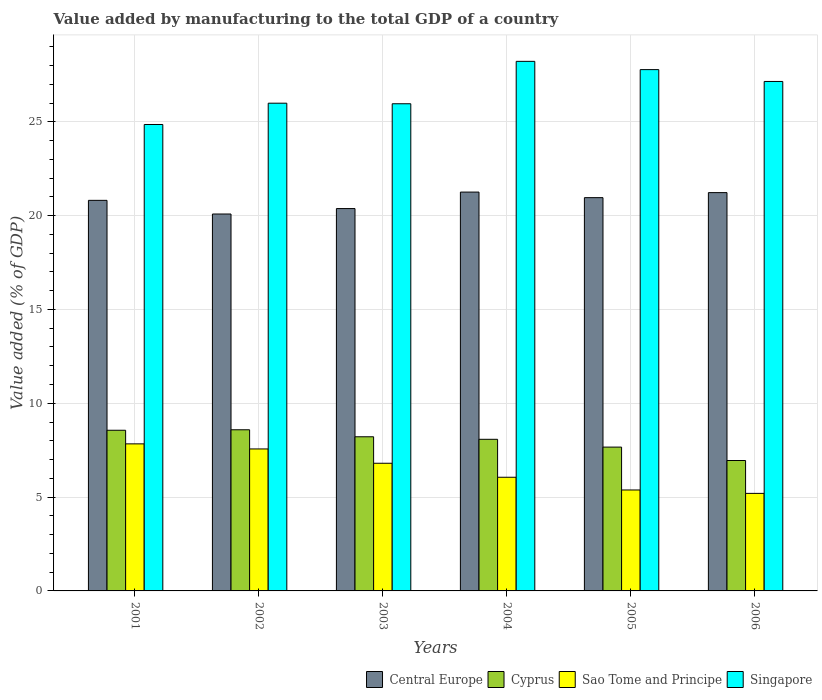Are the number of bars on each tick of the X-axis equal?
Provide a succinct answer. Yes. How many bars are there on the 6th tick from the left?
Provide a succinct answer. 4. How many bars are there on the 3rd tick from the right?
Offer a terse response. 4. What is the label of the 4th group of bars from the left?
Keep it short and to the point. 2004. What is the value added by manufacturing to the total GDP in Sao Tome and Principe in 2003?
Make the answer very short. 6.8. Across all years, what is the maximum value added by manufacturing to the total GDP in Sao Tome and Principe?
Provide a short and direct response. 7.84. Across all years, what is the minimum value added by manufacturing to the total GDP in Singapore?
Make the answer very short. 24.86. What is the total value added by manufacturing to the total GDP in Cyprus in the graph?
Ensure brevity in your answer.  48.06. What is the difference between the value added by manufacturing to the total GDP in Central Europe in 2001 and that in 2005?
Make the answer very short. -0.14. What is the difference between the value added by manufacturing to the total GDP in Central Europe in 2005 and the value added by manufacturing to the total GDP in Sao Tome and Principe in 2002?
Your answer should be compact. 13.39. What is the average value added by manufacturing to the total GDP in Sao Tome and Principe per year?
Make the answer very short. 6.47. In the year 2002, what is the difference between the value added by manufacturing to the total GDP in Central Europe and value added by manufacturing to the total GDP in Sao Tome and Principe?
Offer a terse response. 12.52. In how many years, is the value added by manufacturing to the total GDP in Cyprus greater than 2 %?
Keep it short and to the point. 6. What is the ratio of the value added by manufacturing to the total GDP in Cyprus in 2003 to that in 2006?
Provide a short and direct response. 1.18. Is the difference between the value added by manufacturing to the total GDP in Central Europe in 2001 and 2005 greater than the difference between the value added by manufacturing to the total GDP in Sao Tome and Principe in 2001 and 2005?
Offer a very short reply. No. What is the difference between the highest and the second highest value added by manufacturing to the total GDP in Singapore?
Provide a succinct answer. 0.44. What is the difference between the highest and the lowest value added by manufacturing to the total GDP in Cyprus?
Ensure brevity in your answer.  1.64. What does the 2nd bar from the left in 2002 represents?
Make the answer very short. Cyprus. What does the 3rd bar from the right in 2004 represents?
Ensure brevity in your answer.  Cyprus. How many bars are there?
Your response must be concise. 24. How many years are there in the graph?
Offer a terse response. 6. What is the difference between two consecutive major ticks on the Y-axis?
Your answer should be very brief. 5. Are the values on the major ticks of Y-axis written in scientific E-notation?
Offer a terse response. No. Does the graph contain grids?
Your answer should be compact. Yes. How are the legend labels stacked?
Make the answer very short. Horizontal. What is the title of the graph?
Keep it short and to the point. Value added by manufacturing to the total GDP of a country. What is the label or title of the X-axis?
Your response must be concise. Years. What is the label or title of the Y-axis?
Make the answer very short. Value added (% of GDP). What is the Value added (% of GDP) of Central Europe in 2001?
Ensure brevity in your answer.  20.81. What is the Value added (% of GDP) of Cyprus in 2001?
Give a very brief answer. 8.56. What is the Value added (% of GDP) in Sao Tome and Principe in 2001?
Make the answer very short. 7.84. What is the Value added (% of GDP) in Singapore in 2001?
Offer a very short reply. 24.86. What is the Value added (% of GDP) in Central Europe in 2002?
Provide a short and direct response. 20.09. What is the Value added (% of GDP) in Cyprus in 2002?
Make the answer very short. 8.59. What is the Value added (% of GDP) of Sao Tome and Principe in 2002?
Your answer should be very brief. 7.57. What is the Value added (% of GDP) in Singapore in 2002?
Provide a succinct answer. 25.99. What is the Value added (% of GDP) of Central Europe in 2003?
Provide a short and direct response. 20.38. What is the Value added (% of GDP) of Cyprus in 2003?
Offer a terse response. 8.21. What is the Value added (% of GDP) in Sao Tome and Principe in 2003?
Offer a terse response. 6.8. What is the Value added (% of GDP) of Singapore in 2003?
Give a very brief answer. 25.96. What is the Value added (% of GDP) of Central Europe in 2004?
Your answer should be very brief. 21.25. What is the Value added (% of GDP) in Cyprus in 2004?
Ensure brevity in your answer.  8.08. What is the Value added (% of GDP) of Sao Tome and Principe in 2004?
Provide a succinct answer. 6.06. What is the Value added (% of GDP) of Singapore in 2004?
Make the answer very short. 28.22. What is the Value added (% of GDP) of Central Europe in 2005?
Ensure brevity in your answer.  20.96. What is the Value added (% of GDP) in Cyprus in 2005?
Offer a terse response. 7.66. What is the Value added (% of GDP) of Sao Tome and Principe in 2005?
Provide a succinct answer. 5.38. What is the Value added (% of GDP) in Singapore in 2005?
Give a very brief answer. 27.78. What is the Value added (% of GDP) in Central Europe in 2006?
Your response must be concise. 21.23. What is the Value added (% of GDP) of Cyprus in 2006?
Offer a terse response. 6.95. What is the Value added (% of GDP) in Sao Tome and Principe in 2006?
Make the answer very short. 5.2. What is the Value added (% of GDP) of Singapore in 2006?
Give a very brief answer. 27.15. Across all years, what is the maximum Value added (% of GDP) of Central Europe?
Give a very brief answer. 21.25. Across all years, what is the maximum Value added (% of GDP) in Cyprus?
Offer a terse response. 8.59. Across all years, what is the maximum Value added (% of GDP) of Sao Tome and Principe?
Your response must be concise. 7.84. Across all years, what is the maximum Value added (% of GDP) of Singapore?
Give a very brief answer. 28.22. Across all years, what is the minimum Value added (% of GDP) of Central Europe?
Make the answer very short. 20.09. Across all years, what is the minimum Value added (% of GDP) in Cyprus?
Ensure brevity in your answer.  6.95. Across all years, what is the minimum Value added (% of GDP) of Sao Tome and Principe?
Provide a succinct answer. 5.2. Across all years, what is the minimum Value added (% of GDP) in Singapore?
Ensure brevity in your answer.  24.86. What is the total Value added (% of GDP) in Central Europe in the graph?
Ensure brevity in your answer.  124.71. What is the total Value added (% of GDP) of Cyprus in the graph?
Make the answer very short. 48.06. What is the total Value added (% of GDP) in Sao Tome and Principe in the graph?
Make the answer very short. 38.84. What is the total Value added (% of GDP) in Singapore in the graph?
Provide a succinct answer. 159.96. What is the difference between the Value added (% of GDP) in Central Europe in 2001 and that in 2002?
Your answer should be compact. 0.73. What is the difference between the Value added (% of GDP) of Cyprus in 2001 and that in 2002?
Your answer should be very brief. -0.03. What is the difference between the Value added (% of GDP) in Sao Tome and Principe in 2001 and that in 2002?
Provide a short and direct response. 0.27. What is the difference between the Value added (% of GDP) in Singapore in 2001 and that in 2002?
Your answer should be very brief. -1.13. What is the difference between the Value added (% of GDP) in Central Europe in 2001 and that in 2003?
Offer a terse response. 0.44. What is the difference between the Value added (% of GDP) in Cyprus in 2001 and that in 2003?
Keep it short and to the point. 0.35. What is the difference between the Value added (% of GDP) of Sao Tome and Principe in 2001 and that in 2003?
Your response must be concise. 1.03. What is the difference between the Value added (% of GDP) in Singapore in 2001 and that in 2003?
Make the answer very short. -1.1. What is the difference between the Value added (% of GDP) of Central Europe in 2001 and that in 2004?
Give a very brief answer. -0.44. What is the difference between the Value added (% of GDP) of Cyprus in 2001 and that in 2004?
Provide a short and direct response. 0.48. What is the difference between the Value added (% of GDP) of Sao Tome and Principe in 2001 and that in 2004?
Offer a terse response. 1.78. What is the difference between the Value added (% of GDP) of Singapore in 2001 and that in 2004?
Keep it short and to the point. -3.36. What is the difference between the Value added (% of GDP) in Central Europe in 2001 and that in 2005?
Offer a very short reply. -0.14. What is the difference between the Value added (% of GDP) of Cyprus in 2001 and that in 2005?
Provide a short and direct response. 0.9. What is the difference between the Value added (% of GDP) in Sao Tome and Principe in 2001 and that in 2005?
Provide a succinct answer. 2.46. What is the difference between the Value added (% of GDP) in Singapore in 2001 and that in 2005?
Your answer should be very brief. -2.92. What is the difference between the Value added (% of GDP) of Central Europe in 2001 and that in 2006?
Offer a very short reply. -0.41. What is the difference between the Value added (% of GDP) in Cyprus in 2001 and that in 2006?
Provide a succinct answer. 1.61. What is the difference between the Value added (% of GDP) in Sao Tome and Principe in 2001 and that in 2006?
Your answer should be very brief. 2.64. What is the difference between the Value added (% of GDP) in Singapore in 2001 and that in 2006?
Make the answer very short. -2.29. What is the difference between the Value added (% of GDP) of Central Europe in 2002 and that in 2003?
Give a very brief answer. -0.29. What is the difference between the Value added (% of GDP) in Cyprus in 2002 and that in 2003?
Offer a very short reply. 0.37. What is the difference between the Value added (% of GDP) in Sao Tome and Principe in 2002 and that in 2003?
Make the answer very short. 0.76. What is the difference between the Value added (% of GDP) of Singapore in 2002 and that in 2003?
Your answer should be compact. 0.03. What is the difference between the Value added (% of GDP) of Central Europe in 2002 and that in 2004?
Your response must be concise. -1.17. What is the difference between the Value added (% of GDP) of Cyprus in 2002 and that in 2004?
Your answer should be compact. 0.51. What is the difference between the Value added (% of GDP) in Sao Tome and Principe in 2002 and that in 2004?
Keep it short and to the point. 1.51. What is the difference between the Value added (% of GDP) in Singapore in 2002 and that in 2004?
Offer a very short reply. -2.23. What is the difference between the Value added (% of GDP) of Central Europe in 2002 and that in 2005?
Offer a terse response. -0.87. What is the difference between the Value added (% of GDP) of Cyprus in 2002 and that in 2005?
Your answer should be compact. 0.92. What is the difference between the Value added (% of GDP) of Sao Tome and Principe in 2002 and that in 2005?
Ensure brevity in your answer.  2.19. What is the difference between the Value added (% of GDP) of Singapore in 2002 and that in 2005?
Ensure brevity in your answer.  -1.79. What is the difference between the Value added (% of GDP) of Central Europe in 2002 and that in 2006?
Give a very brief answer. -1.14. What is the difference between the Value added (% of GDP) in Cyprus in 2002 and that in 2006?
Your response must be concise. 1.64. What is the difference between the Value added (% of GDP) of Sao Tome and Principe in 2002 and that in 2006?
Provide a succinct answer. 2.37. What is the difference between the Value added (% of GDP) in Singapore in 2002 and that in 2006?
Ensure brevity in your answer.  -1.16. What is the difference between the Value added (% of GDP) in Central Europe in 2003 and that in 2004?
Ensure brevity in your answer.  -0.88. What is the difference between the Value added (% of GDP) in Cyprus in 2003 and that in 2004?
Ensure brevity in your answer.  0.14. What is the difference between the Value added (% of GDP) in Sao Tome and Principe in 2003 and that in 2004?
Your answer should be compact. 0.75. What is the difference between the Value added (% of GDP) of Singapore in 2003 and that in 2004?
Provide a succinct answer. -2.26. What is the difference between the Value added (% of GDP) of Central Europe in 2003 and that in 2005?
Your answer should be compact. -0.58. What is the difference between the Value added (% of GDP) in Cyprus in 2003 and that in 2005?
Provide a short and direct response. 0.55. What is the difference between the Value added (% of GDP) in Sao Tome and Principe in 2003 and that in 2005?
Keep it short and to the point. 1.42. What is the difference between the Value added (% of GDP) in Singapore in 2003 and that in 2005?
Offer a very short reply. -1.82. What is the difference between the Value added (% of GDP) of Central Europe in 2003 and that in 2006?
Make the answer very short. -0.85. What is the difference between the Value added (% of GDP) of Cyprus in 2003 and that in 2006?
Your response must be concise. 1.27. What is the difference between the Value added (% of GDP) in Sao Tome and Principe in 2003 and that in 2006?
Give a very brief answer. 1.61. What is the difference between the Value added (% of GDP) in Singapore in 2003 and that in 2006?
Offer a very short reply. -1.19. What is the difference between the Value added (% of GDP) in Central Europe in 2004 and that in 2005?
Your answer should be very brief. 0.3. What is the difference between the Value added (% of GDP) of Cyprus in 2004 and that in 2005?
Offer a very short reply. 0.42. What is the difference between the Value added (% of GDP) of Sao Tome and Principe in 2004 and that in 2005?
Offer a terse response. 0.68. What is the difference between the Value added (% of GDP) in Singapore in 2004 and that in 2005?
Your response must be concise. 0.44. What is the difference between the Value added (% of GDP) in Central Europe in 2004 and that in 2006?
Provide a succinct answer. 0.03. What is the difference between the Value added (% of GDP) in Cyprus in 2004 and that in 2006?
Provide a short and direct response. 1.13. What is the difference between the Value added (% of GDP) in Sao Tome and Principe in 2004 and that in 2006?
Provide a short and direct response. 0.86. What is the difference between the Value added (% of GDP) of Singapore in 2004 and that in 2006?
Make the answer very short. 1.07. What is the difference between the Value added (% of GDP) in Central Europe in 2005 and that in 2006?
Your response must be concise. -0.27. What is the difference between the Value added (% of GDP) of Cyprus in 2005 and that in 2006?
Ensure brevity in your answer.  0.71. What is the difference between the Value added (% of GDP) of Sao Tome and Principe in 2005 and that in 2006?
Offer a terse response. 0.18. What is the difference between the Value added (% of GDP) in Singapore in 2005 and that in 2006?
Offer a terse response. 0.63. What is the difference between the Value added (% of GDP) in Central Europe in 2001 and the Value added (% of GDP) in Cyprus in 2002?
Your answer should be compact. 12.23. What is the difference between the Value added (% of GDP) of Central Europe in 2001 and the Value added (% of GDP) of Sao Tome and Principe in 2002?
Provide a succinct answer. 13.25. What is the difference between the Value added (% of GDP) of Central Europe in 2001 and the Value added (% of GDP) of Singapore in 2002?
Your response must be concise. -5.18. What is the difference between the Value added (% of GDP) of Cyprus in 2001 and the Value added (% of GDP) of Singapore in 2002?
Offer a terse response. -17.43. What is the difference between the Value added (% of GDP) of Sao Tome and Principe in 2001 and the Value added (% of GDP) of Singapore in 2002?
Make the answer very short. -18.15. What is the difference between the Value added (% of GDP) in Central Europe in 2001 and the Value added (% of GDP) in Cyprus in 2003?
Your answer should be compact. 12.6. What is the difference between the Value added (% of GDP) in Central Europe in 2001 and the Value added (% of GDP) in Sao Tome and Principe in 2003?
Your response must be concise. 14.01. What is the difference between the Value added (% of GDP) in Central Europe in 2001 and the Value added (% of GDP) in Singapore in 2003?
Give a very brief answer. -5.15. What is the difference between the Value added (% of GDP) of Cyprus in 2001 and the Value added (% of GDP) of Sao Tome and Principe in 2003?
Offer a terse response. 1.76. What is the difference between the Value added (% of GDP) in Cyprus in 2001 and the Value added (% of GDP) in Singapore in 2003?
Ensure brevity in your answer.  -17.4. What is the difference between the Value added (% of GDP) in Sao Tome and Principe in 2001 and the Value added (% of GDP) in Singapore in 2003?
Your answer should be compact. -18.12. What is the difference between the Value added (% of GDP) of Central Europe in 2001 and the Value added (% of GDP) of Cyprus in 2004?
Your answer should be very brief. 12.73. What is the difference between the Value added (% of GDP) of Central Europe in 2001 and the Value added (% of GDP) of Sao Tome and Principe in 2004?
Your answer should be very brief. 14.76. What is the difference between the Value added (% of GDP) in Central Europe in 2001 and the Value added (% of GDP) in Singapore in 2004?
Provide a succinct answer. -7.41. What is the difference between the Value added (% of GDP) of Cyprus in 2001 and the Value added (% of GDP) of Sao Tome and Principe in 2004?
Give a very brief answer. 2.5. What is the difference between the Value added (% of GDP) in Cyprus in 2001 and the Value added (% of GDP) in Singapore in 2004?
Offer a very short reply. -19.66. What is the difference between the Value added (% of GDP) of Sao Tome and Principe in 2001 and the Value added (% of GDP) of Singapore in 2004?
Keep it short and to the point. -20.38. What is the difference between the Value added (% of GDP) in Central Europe in 2001 and the Value added (% of GDP) in Cyprus in 2005?
Offer a very short reply. 13.15. What is the difference between the Value added (% of GDP) in Central Europe in 2001 and the Value added (% of GDP) in Sao Tome and Principe in 2005?
Your response must be concise. 15.43. What is the difference between the Value added (% of GDP) in Central Europe in 2001 and the Value added (% of GDP) in Singapore in 2005?
Make the answer very short. -6.97. What is the difference between the Value added (% of GDP) in Cyprus in 2001 and the Value added (% of GDP) in Sao Tome and Principe in 2005?
Your answer should be very brief. 3.18. What is the difference between the Value added (% of GDP) in Cyprus in 2001 and the Value added (% of GDP) in Singapore in 2005?
Offer a very short reply. -19.22. What is the difference between the Value added (% of GDP) in Sao Tome and Principe in 2001 and the Value added (% of GDP) in Singapore in 2005?
Provide a short and direct response. -19.94. What is the difference between the Value added (% of GDP) of Central Europe in 2001 and the Value added (% of GDP) of Cyprus in 2006?
Offer a terse response. 13.86. What is the difference between the Value added (% of GDP) in Central Europe in 2001 and the Value added (% of GDP) in Sao Tome and Principe in 2006?
Provide a short and direct response. 15.62. What is the difference between the Value added (% of GDP) of Central Europe in 2001 and the Value added (% of GDP) of Singapore in 2006?
Your answer should be compact. -6.34. What is the difference between the Value added (% of GDP) of Cyprus in 2001 and the Value added (% of GDP) of Sao Tome and Principe in 2006?
Keep it short and to the point. 3.36. What is the difference between the Value added (% of GDP) in Cyprus in 2001 and the Value added (% of GDP) in Singapore in 2006?
Make the answer very short. -18.59. What is the difference between the Value added (% of GDP) of Sao Tome and Principe in 2001 and the Value added (% of GDP) of Singapore in 2006?
Offer a very short reply. -19.31. What is the difference between the Value added (% of GDP) in Central Europe in 2002 and the Value added (% of GDP) in Cyprus in 2003?
Provide a short and direct response. 11.87. What is the difference between the Value added (% of GDP) in Central Europe in 2002 and the Value added (% of GDP) in Sao Tome and Principe in 2003?
Make the answer very short. 13.28. What is the difference between the Value added (% of GDP) of Central Europe in 2002 and the Value added (% of GDP) of Singapore in 2003?
Your answer should be compact. -5.88. What is the difference between the Value added (% of GDP) in Cyprus in 2002 and the Value added (% of GDP) in Sao Tome and Principe in 2003?
Give a very brief answer. 1.78. What is the difference between the Value added (% of GDP) of Cyprus in 2002 and the Value added (% of GDP) of Singapore in 2003?
Offer a terse response. -17.37. What is the difference between the Value added (% of GDP) of Sao Tome and Principe in 2002 and the Value added (% of GDP) of Singapore in 2003?
Keep it short and to the point. -18.4. What is the difference between the Value added (% of GDP) of Central Europe in 2002 and the Value added (% of GDP) of Cyprus in 2004?
Offer a terse response. 12.01. What is the difference between the Value added (% of GDP) in Central Europe in 2002 and the Value added (% of GDP) in Sao Tome and Principe in 2004?
Keep it short and to the point. 14.03. What is the difference between the Value added (% of GDP) of Central Europe in 2002 and the Value added (% of GDP) of Singapore in 2004?
Your answer should be compact. -8.14. What is the difference between the Value added (% of GDP) in Cyprus in 2002 and the Value added (% of GDP) in Sao Tome and Principe in 2004?
Make the answer very short. 2.53. What is the difference between the Value added (% of GDP) in Cyprus in 2002 and the Value added (% of GDP) in Singapore in 2004?
Provide a succinct answer. -19.63. What is the difference between the Value added (% of GDP) in Sao Tome and Principe in 2002 and the Value added (% of GDP) in Singapore in 2004?
Keep it short and to the point. -20.66. What is the difference between the Value added (% of GDP) of Central Europe in 2002 and the Value added (% of GDP) of Cyprus in 2005?
Offer a terse response. 12.42. What is the difference between the Value added (% of GDP) of Central Europe in 2002 and the Value added (% of GDP) of Sao Tome and Principe in 2005?
Keep it short and to the point. 14.71. What is the difference between the Value added (% of GDP) in Central Europe in 2002 and the Value added (% of GDP) in Singapore in 2005?
Your response must be concise. -7.7. What is the difference between the Value added (% of GDP) of Cyprus in 2002 and the Value added (% of GDP) of Sao Tome and Principe in 2005?
Offer a terse response. 3.21. What is the difference between the Value added (% of GDP) in Cyprus in 2002 and the Value added (% of GDP) in Singapore in 2005?
Make the answer very short. -19.19. What is the difference between the Value added (% of GDP) in Sao Tome and Principe in 2002 and the Value added (% of GDP) in Singapore in 2005?
Ensure brevity in your answer.  -20.22. What is the difference between the Value added (% of GDP) in Central Europe in 2002 and the Value added (% of GDP) in Cyprus in 2006?
Your answer should be very brief. 13.14. What is the difference between the Value added (% of GDP) of Central Europe in 2002 and the Value added (% of GDP) of Sao Tome and Principe in 2006?
Ensure brevity in your answer.  14.89. What is the difference between the Value added (% of GDP) in Central Europe in 2002 and the Value added (% of GDP) in Singapore in 2006?
Give a very brief answer. -7.06. What is the difference between the Value added (% of GDP) of Cyprus in 2002 and the Value added (% of GDP) of Sao Tome and Principe in 2006?
Your answer should be very brief. 3.39. What is the difference between the Value added (% of GDP) in Cyprus in 2002 and the Value added (% of GDP) in Singapore in 2006?
Make the answer very short. -18.56. What is the difference between the Value added (% of GDP) of Sao Tome and Principe in 2002 and the Value added (% of GDP) of Singapore in 2006?
Provide a succinct answer. -19.58. What is the difference between the Value added (% of GDP) of Central Europe in 2003 and the Value added (% of GDP) of Cyprus in 2004?
Give a very brief answer. 12.3. What is the difference between the Value added (% of GDP) in Central Europe in 2003 and the Value added (% of GDP) in Sao Tome and Principe in 2004?
Your response must be concise. 14.32. What is the difference between the Value added (% of GDP) in Central Europe in 2003 and the Value added (% of GDP) in Singapore in 2004?
Your answer should be compact. -7.85. What is the difference between the Value added (% of GDP) in Cyprus in 2003 and the Value added (% of GDP) in Sao Tome and Principe in 2004?
Your response must be concise. 2.16. What is the difference between the Value added (% of GDP) in Cyprus in 2003 and the Value added (% of GDP) in Singapore in 2004?
Offer a very short reply. -20.01. What is the difference between the Value added (% of GDP) of Sao Tome and Principe in 2003 and the Value added (% of GDP) of Singapore in 2004?
Keep it short and to the point. -21.42. What is the difference between the Value added (% of GDP) in Central Europe in 2003 and the Value added (% of GDP) in Cyprus in 2005?
Your response must be concise. 12.71. What is the difference between the Value added (% of GDP) in Central Europe in 2003 and the Value added (% of GDP) in Sao Tome and Principe in 2005?
Offer a very short reply. 15. What is the difference between the Value added (% of GDP) in Central Europe in 2003 and the Value added (% of GDP) in Singapore in 2005?
Provide a short and direct response. -7.41. What is the difference between the Value added (% of GDP) in Cyprus in 2003 and the Value added (% of GDP) in Sao Tome and Principe in 2005?
Provide a succinct answer. 2.84. What is the difference between the Value added (% of GDP) in Cyprus in 2003 and the Value added (% of GDP) in Singapore in 2005?
Provide a short and direct response. -19.57. What is the difference between the Value added (% of GDP) in Sao Tome and Principe in 2003 and the Value added (% of GDP) in Singapore in 2005?
Your answer should be compact. -20.98. What is the difference between the Value added (% of GDP) in Central Europe in 2003 and the Value added (% of GDP) in Cyprus in 2006?
Your response must be concise. 13.43. What is the difference between the Value added (% of GDP) in Central Europe in 2003 and the Value added (% of GDP) in Sao Tome and Principe in 2006?
Give a very brief answer. 15.18. What is the difference between the Value added (% of GDP) in Central Europe in 2003 and the Value added (% of GDP) in Singapore in 2006?
Your answer should be very brief. -6.77. What is the difference between the Value added (% of GDP) of Cyprus in 2003 and the Value added (% of GDP) of Sao Tome and Principe in 2006?
Provide a succinct answer. 3.02. What is the difference between the Value added (% of GDP) in Cyprus in 2003 and the Value added (% of GDP) in Singapore in 2006?
Your answer should be compact. -18.94. What is the difference between the Value added (% of GDP) of Sao Tome and Principe in 2003 and the Value added (% of GDP) of Singapore in 2006?
Keep it short and to the point. -20.35. What is the difference between the Value added (% of GDP) in Central Europe in 2004 and the Value added (% of GDP) in Cyprus in 2005?
Provide a succinct answer. 13.59. What is the difference between the Value added (% of GDP) in Central Europe in 2004 and the Value added (% of GDP) in Sao Tome and Principe in 2005?
Make the answer very short. 15.87. What is the difference between the Value added (% of GDP) in Central Europe in 2004 and the Value added (% of GDP) in Singapore in 2005?
Offer a very short reply. -6.53. What is the difference between the Value added (% of GDP) of Cyprus in 2004 and the Value added (% of GDP) of Sao Tome and Principe in 2005?
Your answer should be very brief. 2.7. What is the difference between the Value added (% of GDP) of Cyprus in 2004 and the Value added (% of GDP) of Singapore in 2005?
Provide a succinct answer. -19.7. What is the difference between the Value added (% of GDP) of Sao Tome and Principe in 2004 and the Value added (% of GDP) of Singapore in 2005?
Keep it short and to the point. -21.72. What is the difference between the Value added (% of GDP) in Central Europe in 2004 and the Value added (% of GDP) in Cyprus in 2006?
Keep it short and to the point. 14.3. What is the difference between the Value added (% of GDP) of Central Europe in 2004 and the Value added (% of GDP) of Sao Tome and Principe in 2006?
Give a very brief answer. 16.06. What is the difference between the Value added (% of GDP) in Central Europe in 2004 and the Value added (% of GDP) in Singapore in 2006?
Your response must be concise. -5.9. What is the difference between the Value added (% of GDP) in Cyprus in 2004 and the Value added (% of GDP) in Sao Tome and Principe in 2006?
Your answer should be very brief. 2.88. What is the difference between the Value added (% of GDP) of Cyprus in 2004 and the Value added (% of GDP) of Singapore in 2006?
Keep it short and to the point. -19.07. What is the difference between the Value added (% of GDP) of Sao Tome and Principe in 2004 and the Value added (% of GDP) of Singapore in 2006?
Your answer should be very brief. -21.09. What is the difference between the Value added (% of GDP) in Central Europe in 2005 and the Value added (% of GDP) in Cyprus in 2006?
Your answer should be very brief. 14.01. What is the difference between the Value added (% of GDP) in Central Europe in 2005 and the Value added (% of GDP) in Sao Tome and Principe in 2006?
Ensure brevity in your answer.  15.76. What is the difference between the Value added (% of GDP) in Central Europe in 2005 and the Value added (% of GDP) in Singapore in 2006?
Your answer should be very brief. -6.19. What is the difference between the Value added (% of GDP) in Cyprus in 2005 and the Value added (% of GDP) in Sao Tome and Principe in 2006?
Keep it short and to the point. 2.47. What is the difference between the Value added (% of GDP) in Cyprus in 2005 and the Value added (% of GDP) in Singapore in 2006?
Make the answer very short. -19.49. What is the difference between the Value added (% of GDP) of Sao Tome and Principe in 2005 and the Value added (% of GDP) of Singapore in 2006?
Offer a terse response. -21.77. What is the average Value added (% of GDP) in Central Europe per year?
Provide a succinct answer. 20.79. What is the average Value added (% of GDP) of Cyprus per year?
Offer a terse response. 8.01. What is the average Value added (% of GDP) in Sao Tome and Principe per year?
Your answer should be compact. 6.47. What is the average Value added (% of GDP) in Singapore per year?
Give a very brief answer. 26.66. In the year 2001, what is the difference between the Value added (% of GDP) in Central Europe and Value added (% of GDP) in Cyprus?
Offer a terse response. 12.25. In the year 2001, what is the difference between the Value added (% of GDP) of Central Europe and Value added (% of GDP) of Sao Tome and Principe?
Your response must be concise. 12.98. In the year 2001, what is the difference between the Value added (% of GDP) of Central Europe and Value added (% of GDP) of Singapore?
Your answer should be very brief. -4.04. In the year 2001, what is the difference between the Value added (% of GDP) of Cyprus and Value added (% of GDP) of Sao Tome and Principe?
Offer a terse response. 0.73. In the year 2001, what is the difference between the Value added (% of GDP) of Cyprus and Value added (% of GDP) of Singapore?
Your answer should be compact. -16.29. In the year 2001, what is the difference between the Value added (% of GDP) in Sao Tome and Principe and Value added (% of GDP) in Singapore?
Offer a terse response. -17.02. In the year 2002, what is the difference between the Value added (% of GDP) of Central Europe and Value added (% of GDP) of Cyprus?
Your answer should be very brief. 11.5. In the year 2002, what is the difference between the Value added (% of GDP) of Central Europe and Value added (% of GDP) of Sao Tome and Principe?
Your answer should be compact. 12.52. In the year 2002, what is the difference between the Value added (% of GDP) of Central Europe and Value added (% of GDP) of Singapore?
Your response must be concise. -5.91. In the year 2002, what is the difference between the Value added (% of GDP) of Cyprus and Value added (% of GDP) of Sao Tome and Principe?
Offer a very short reply. 1.02. In the year 2002, what is the difference between the Value added (% of GDP) of Cyprus and Value added (% of GDP) of Singapore?
Offer a very short reply. -17.4. In the year 2002, what is the difference between the Value added (% of GDP) of Sao Tome and Principe and Value added (% of GDP) of Singapore?
Offer a terse response. -18.43. In the year 2003, what is the difference between the Value added (% of GDP) in Central Europe and Value added (% of GDP) in Cyprus?
Your answer should be compact. 12.16. In the year 2003, what is the difference between the Value added (% of GDP) of Central Europe and Value added (% of GDP) of Sao Tome and Principe?
Your answer should be very brief. 13.57. In the year 2003, what is the difference between the Value added (% of GDP) in Central Europe and Value added (% of GDP) in Singapore?
Your answer should be compact. -5.59. In the year 2003, what is the difference between the Value added (% of GDP) in Cyprus and Value added (% of GDP) in Sao Tome and Principe?
Make the answer very short. 1.41. In the year 2003, what is the difference between the Value added (% of GDP) in Cyprus and Value added (% of GDP) in Singapore?
Ensure brevity in your answer.  -17.75. In the year 2003, what is the difference between the Value added (% of GDP) in Sao Tome and Principe and Value added (% of GDP) in Singapore?
Give a very brief answer. -19.16. In the year 2004, what is the difference between the Value added (% of GDP) in Central Europe and Value added (% of GDP) in Cyprus?
Provide a succinct answer. 13.17. In the year 2004, what is the difference between the Value added (% of GDP) in Central Europe and Value added (% of GDP) in Sao Tome and Principe?
Your answer should be compact. 15.2. In the year 2004, what is the difference between the Value added (% of GDP) in Central Europe and Value added (% of GDP) in Singapore?
Make the answer very short. -6.97. In the year 2004, what is the difference between the Value added (% of GDP) of Cyprus and Value added (% of GDP) of Sao Tome and Principe?
Offer a very short reply. 2.02. In the year 2004, what is the difference between the Value added (% of GDP) of Cyprus and Value added (% of GDP) of Singapore?
Keep it short and to the point. -20.14. In the year 2004, what is the difference between the Value added (% of GDP) of Sao Tome and Principe and Value added (% of GDP) of Singapore?
Keep it short and to the point. -22.16. In the year 2005, what is the difference between the Value added (% of GDP) in Central Europe and Value added (% of GDP) in Cyprus?
Your answer should be compact. 13.29. In the year 2005, what is the difference between the Value added (% of GDP) in Central Europe and Value added (% of GDP) in Sao Tome and Principe?
Your response must be concise. 15.58. In the year 2005, what is the difference between the Value added (% of GDP) of Central Europe and Value added (% of GDP) of Singapore?
Provide a short and direct response. -6.82. In the year 2005, what is the difference between the Value added (% of GDP) in Cyprus and Value added (% of GDP) in Sao Tome and Principe?
Offer a terse response. 2.28. In the year 2005, what is the difference between the Value added (% of GDP) of Cyprus and Value added (% of GDP) of Singapore?
Offer a very short reply. -20.12. In the year 2005, what is the difference between the Value added (% of GDP) of Sao Tome and Principe and Value added (% of GDP) of Singapore?
Give a very brief answer. -22.4. In the year 2006, what is the difference between the Value added (% of GDP) of Central Europe and Value added (% of GDP) of Cyprus?
Your answer should be very brief. 14.28. In the year 2006, what is the difference between the Value added (% of GDP) of Central Europe and Value added (% of GDP) of Sao Tome and Principe?
Keep it short and to the point. 16.03. In the year 2006, what is the difference between the Value added (% of GDP) in Central Europe and Value added (% of GDP) in Singapore?
Your answer should be very brief. -5.92. In the year 2006, what is the difference between the Value added (% of GDP) in Cyprus and Value added (% of GDP) in Sao Tome and Principe?
Provide a short and direct response. 1.75. In the year 2006, what is the difference between the Value added (% of GDP) in Cyprus and Value added (% of GDP) in Singapore?
Offer a very short reply. -20.2. In the year 2006, what is the difference between the Value added (% of GDP) of Sao Tome and Principe and Value added (% of GDP) of Singapore?
Keep it short and to the point. -21.95. What is the ratio of the Value added (% of GDP) in Central Europe in 2001 to that in 2002?
Keep it short and to the point. 1.04. What is the ratio of the Value added (% of GDP) in Cyprus in 2001 to that in 2002?
Give a very brief answer. 1. What is the ratio of the Value added (% of GDP) of Sao Tome and Principe in 2001 to that in 2002?
Your answer should be very brief. 1.04. What is the ratio of the Value added (% of GDP) of Singapore in 2001 to that in 2002?
Keep it short and to the point. 0.96. What is the ratio of the Value added (% of GDP) of Central Europe in 2001 to that in 2003?
Make the answer very short. 1.02. What is the ratio of the Value added (% of GDP) of Cyprus in 2001 to that in 2003?
Provide a succinct answer. 1.04. What is the ratio of the Value added (% of GDP) in Sao Tome and Principe in 2001 to that in 2003?
Make the answer very short. 1.15. What is the ratio of the Value added (% of GDP) in Singapore in 2001 to that in 2003?
Your answer should be compact. 0.96. What is the ratio of the Value added (% of GDP) in Central Europe in 2001 to that in 2004?
Make the answer very short. 0.98. What is the ratio of the Value added (% of GDP) in Cyprus in 2001 to that in 2004?
Keep it short and to the point. 1.06. What is the ratio of the Value added (% of GDP) in Sao Tome and Principe in 2001 to that in 2004?
Make the answer very short. 1.29. What is the ratio of the Value added (% of GDP) of Singapore in 2001 to that in 2004?
Offer a very short reply. 0.88. What is the ratio of the Value added (% of GDP) in Central Europe in 2001 to that in 2005?
Your answer should be very brief. 0.99. What is the ratio of the Value added (% of GDP) of Cyprus in 2001 to that in 2005?
Provide a succinct answer. 1.12. What is the ratio of the Value added (% of GDP) in Sao Tome and Principe in 2001 to that in 2005?
Provide a succinct answer. 1.46. What is the ratio of the Value added (% of GDP) of Singapore in 2001 to that in 2005?
Make the answer very short. 0.89. What is the ratio of the Value added (% of GDP) of Central Europe in 2001 to that in 2006?
Make the answer very short. 0.98. What is the ratio of the Value added (% of GDP) in Cyprus in 2001 to that in 2006?
Provide a short and direct response. 1.23. What is the ratio of the Value added (% of GDP) of Sao Tome and Principe in 2001 to that in 2006?
Your answer should be very brief. 1.51. What is the ratio of the Value added (% of GDP) of Singapore in 2001 to that in 2006?
Keep it short and to the point. 0.92. What is the ratio of the Value added (% of GDP) of Central Europe in 2002 to that in 2003?
Ensure brevity in your answer.  0.99. What is the ratio of the Value added (% of GDP) in Cyprus in 2002 to that in 2003?
Your answer should be very brief. 1.05. What is the ratio of the Value added (% of GDP) of Sao Tome and Principe in 2002 to that in 2003?
Provide a succinct answer. 1.11. What is the ratio of the Value added (% of GDP) of Singapore in 2002 to that in 2003?
Provide a succinct answer. 1. What is the ratio of the Value added (% of GDP) of Central Europe in 2002 to that in 2004?
Provide a succinct answer. 0.94. What is the ratio of the Value added (% of GDP) in Cyprus in 2002 to that in 2004?
Provide a short and direct response. 1.06. What is the ratio of the Value added (% of GDP) in Sao Tome and Principe in 2002 to that in 2004?
Provide a succinct answer. 1.25. What is the ratio of the Value added (% of GDP) in Singapore in 2002 to that in 2004?
Keep it short and to the point. 0.92. What is the ratio of the Value added (% of GDP) of Central Europe in 2002 to that in 2005?
Keep it short and to the point. 0.96. What is the ratio of the Value added (% of GDP) of Cyprus in 2002 to that in 2005?
Keep it short and to the point. 1.12. What is the ratio of the Value added (% of GDP) in Sao Tome and Principe in 2002 to that in 2005?
Provide a short and direct response. 1.41. What is the ratio of the Value added (% of GDP) in Singapore in 2002 to that in 2005?
Provide a succinct answer. 0.94. What is the ratio of the Value added (% of GDP) of Central Europe in 2002 to that in 2006?
Provide a short and direct response. 0.95. What is the ratio of the Value added (% of GDP) in Cyprus in 2002 to that in 2006?
Make the answer very short. 1.24. What is the ratio of the Value added (% of GDP) of Sao Tome and Principe in 2002 to that in 2006?
Your answer should be very brief. 1.46. What is the ratio of the Value added (% of GDP) in Singapore in 2002 to that in 2006?
Provide a succinct answer. 0.96. What is the ratio of the Value added (% of GDP) in Central Europe in 2003 to that in 2004?
Give a very brief answer. 0.96. What is the ratio of the Value added (% of GDP) in Cyprus in 2003 to that in 2004?
Provide a short and direct response. 1.02. What is the ratio of the Value added (% of GDP) of Sao Tome and Principe in 2003 to that in 2004?
Offer a terse response. 1.12. What is the ratio of the Value added (% of GDP) in Singapore in 2003 to that in 2004?
Keep it short and to the point. 0.92. What is the ratio of the Value added (% of GDP) of Central Europe in 2003 to that in 2005?
Ensure brevity in your answer.  0.97. What is the ratio of the Value added (% of GDP) of Cyprus in 2003 to that in 2005?
Provide a succinct answer. 1.07. What is the ratio of the Value added (% of GDP) of Sao Tome and Principe in 2003 to that in 2005?
Offer a very short reply. 1.26. What is the ratio of the Value added (% of GDP) in Singapore in 2003 to that in 2005?
Keep it short and to the point. 0.93. What is the ratio of the Value added (% of GDP) in Central Europe in 2003 to that in 2006?
Your answer should be very brief. 0.96. What is the ratio of the Value added (% of GDP) in Cyprus in 2003 to that in 2006?
Make the answer very short. 1.18. What is the ratio of the Value added (% of GDP) in Sao Tome and Principe in 2003 to that in 2006?
Provide a short and direct response. 1.31. What is the ratio of the Value added (% of GDP) of Singapore in 2003 to that in 2006?
Your answer should be compact. 0.96. What is the ratio of the Value added (% of GDP) of Central Europe in 2004 to that in 2005?
Offer a very short reply. 1.01. What is the ratio of the Value added (% of GDP) of Cyprus in 2004 to that in 2005?
Give a very brief answer. 1.05. What is the ratio of the Value added (% of GDP) in Sao Tome and Principe in 2004 to that in 2005?
Keep it short and to the point. 1.13. What is the ratio of the Value added (% of GDP) of Singapore in 2004 to that in 2005?
Your answer should be very brief. 1.02. What is the ratio of the Value added (% of GDP) of Cyprus in 2004 to that in 2006?
Give a very brief answer. 1.16. What is the ratio of the Value added (% of GDP) in Sao Tome and Principe in 2004 to that in 2006?
Provide a succinct answer. 1.17. What is the ratio of the Value added (% of GDP) in Singapore in 2004 to that in 2006?
Ensure brevity in your answer.  1.04. What is the ratio of the Value added (% of GDP) in Central Europe in 2005 to that in 2006?
Your answer should be compact. 0.99. What is the ratio of the Value added (% of GDP) in Cyprus in 2005 to that in 2006?
Provide a succinct answer. 1.1. What is the ratio of the Value added (% of GDP) in Sao Tome and Principe in 2005 to that in 2006?
Ensure brevity in your answer.  1.03. What is the ratio of the Value added (% of GDP) of Singapore in 2005 to that in 2006?
Offer a terse response. 1.02. What is the difference between the highest and the second highest Value added (% of GDP) in Central Europe?
Your answer should be compact. 0.03. What is the difference between the highest and the second highest Value added (% of GDP) in Cyprus?
Ensure brevity in your answer.  0.03. What is the difference between the highest and the second highest Value added (% of GDP) of Sao Tome and Principe?
Ensure brevity in your answer.  0.27. What is the difference between the highest and the second highest Value added (% of GDP) in Singapore?
Make the answer very short. 0.44. What is the difference between the highest and the lowest Value added (% of GDP) in Central Europe?
Offer a terse response. 1.17. What is the difference between the highest and the lowest Value added (% of GDP) in Cyprus?
Provide a succinct answer. 1.64. What is the difference between the highest and the lowest Value added (% of GDP) of Sao Tome and Principe?
Keep it short and to the point. 2.64. What is the difference between the highest and the lowest Value added (% of GDP) in Singapore?
Keep it short and to the point. 3.36. 